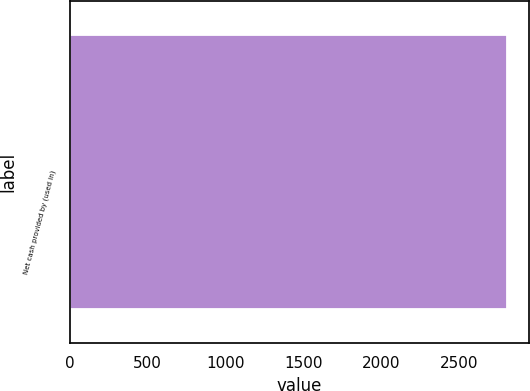<chart> <loc_0><loc_0><loc_500><loc_500><bar_chart><fcel>Net cash provided by (used in)<nl><fcel>2808<nl></chart> 